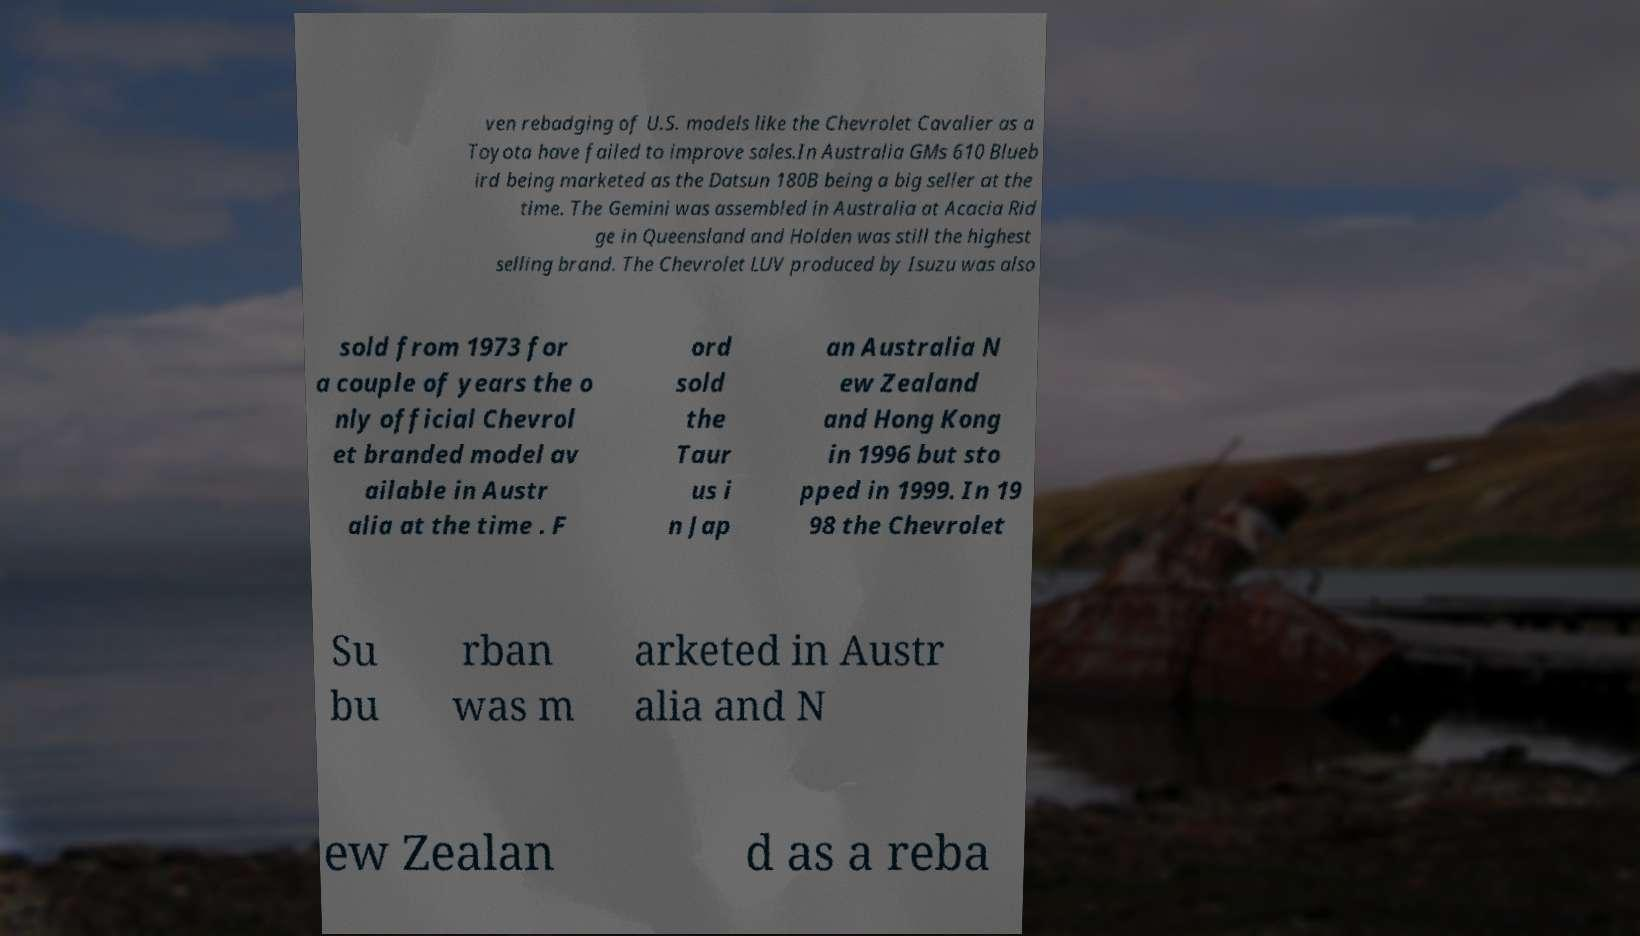Could you assist in decoding the text presented in this image and type it out clearly? ven rebadging of U.S. models like the Chevrolet Cavalier as a Toyota have failed to improve sales.In Australia GMs 610 Blueb ird being marketed as the Datsun 180B being a big seller at the time. The Gemini was assembled in Australia at Acacia Rid ge in Queensland and Holden was still the highest selling brand. The Chevrolet LUV produced by Isuzu was also sold from 1973 for a couple of years the o nly official Chevrol et branded model av ailable in Austr alia at the time . F ord sold the Taur us i n Jap an Australia N ew Zealand and Hong Kong in 1996 but sto pped in 1999. In 19 98 the Chevrolet Su bu rban was m arketed in Austr alia and N ew Zealan d as a reba 